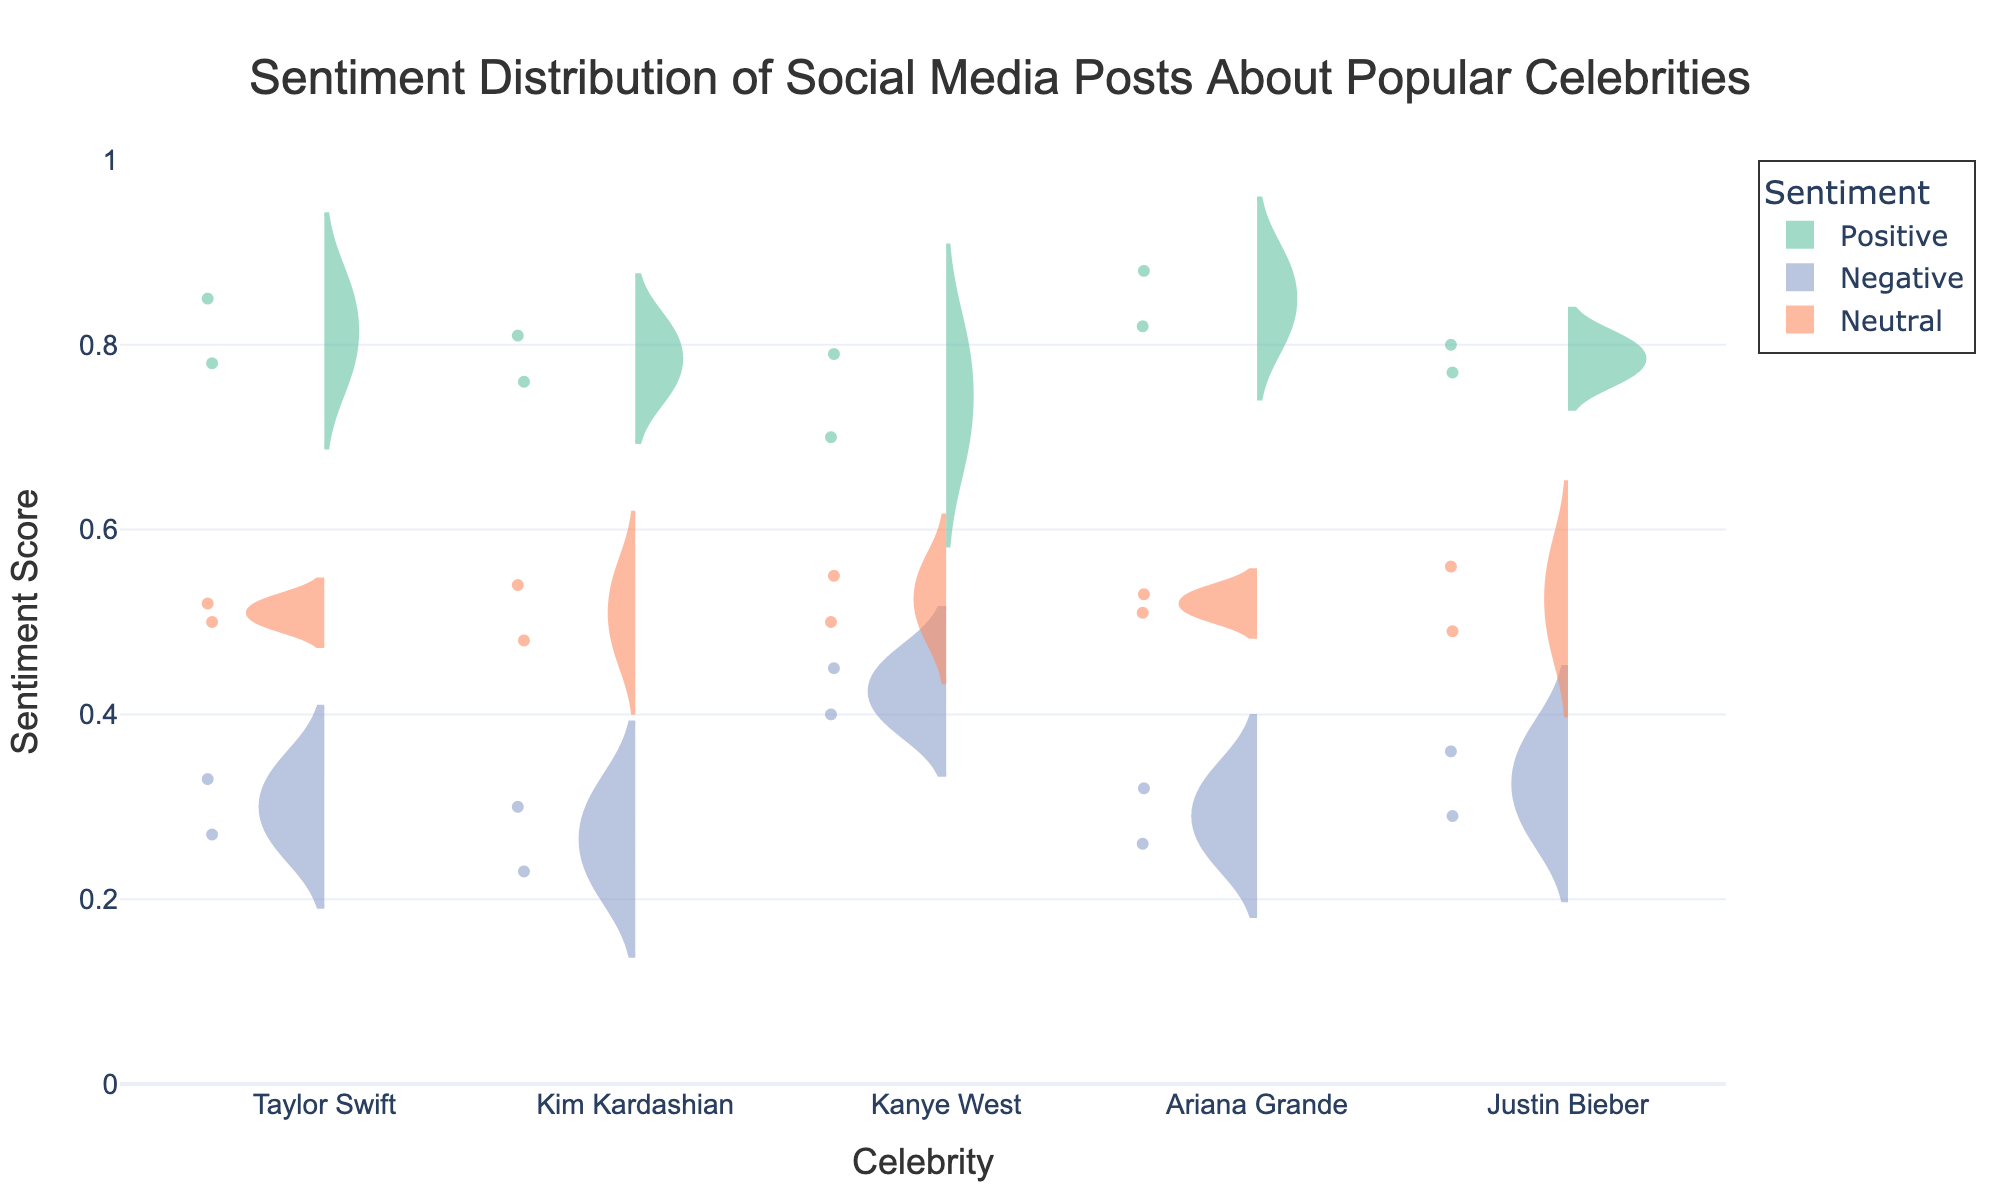What is the title of the figure? The title is usually placed at the top of the figure and is meant to represent what the figure is about. In this case, the title directly shows what the data and figure represent.
Answer: Sentiment Distribution of Social Media Posts About Popular Celebrities Which sentiment color represents Positive posts? The color of the traces for positive sentiment posts is specified as '#66c2a5', a shade of green, which is consistent in the figure.
Answer: Green How many celebrities are represented in the figure? The x-axis labels or categories represent the number of celebrities included. By counting them, we can determine the number.
Answer: Five Which celebrity has the highest median score for Positive sentiment? To determine the median score, we look at the central line in the violin plot for each celebrity within the Positive sentiment traces.
Answer: Ariana Grande What is the range of sentiment scores displayed on the y-axis? The y-axis of the figure shows the range of sentiment scores, which can be identified by the labels at the bottom and top ends of the axis.
Answer: 0 to 1 Which celebrity shows more variation in Negative sentiment scores, Kanye West or Kim Kardashian? Variation can be assessed by looking at the width and spread of the violin plots for the Negative sentiment. Wider and more spread out plots indicate more variation.
Answer: Kanye West What type of plot does this figure use? The figure utilizes a specific type of plot that is suitable for comparing distributions of data across categories, especially with multiple sentiment layers.
Answer: Split Violin Chart Which sentiment generally appears least frequent across all celebrities? The frequency can be judged by the density and thickness of the violin plots. The less frequent sentiment will have a thinner and less dense plot.
Answer: Neutral Calculate the average Positive sentiment score for Justin Bieber? The Positive sentiment scores for Justin Bieber are 0.80 and 0.77. By summing these and dividing by the number of scores, the average can be found. (0.80 + 0.77) / 2 = 0.785
Answer: 0.785 Which sentiment for Taylor Swift has a closer value to the median of Neutral sentiment scores? To determine this, compare the Neutral sentiment value at the median line for Taylor Swift and find which sentiment (Positive or Negative) is numerically closer.
Answer: Neutral 